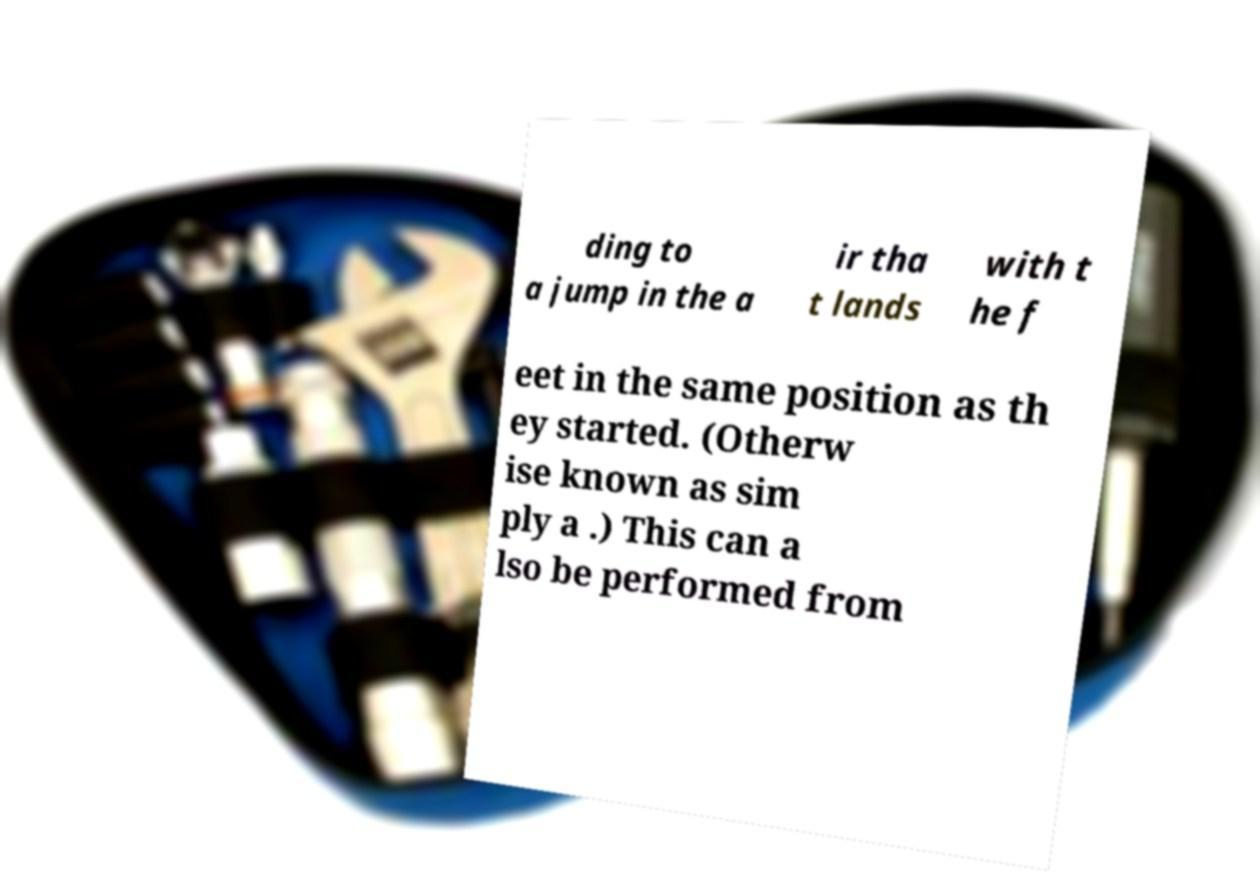Could you extract and type out the text from this image? ding to a jump in the a ir tha t lands with t he f eet in the same position as th ey started. (Otherw ise known as sim ply a .) This can a lso be performed from 